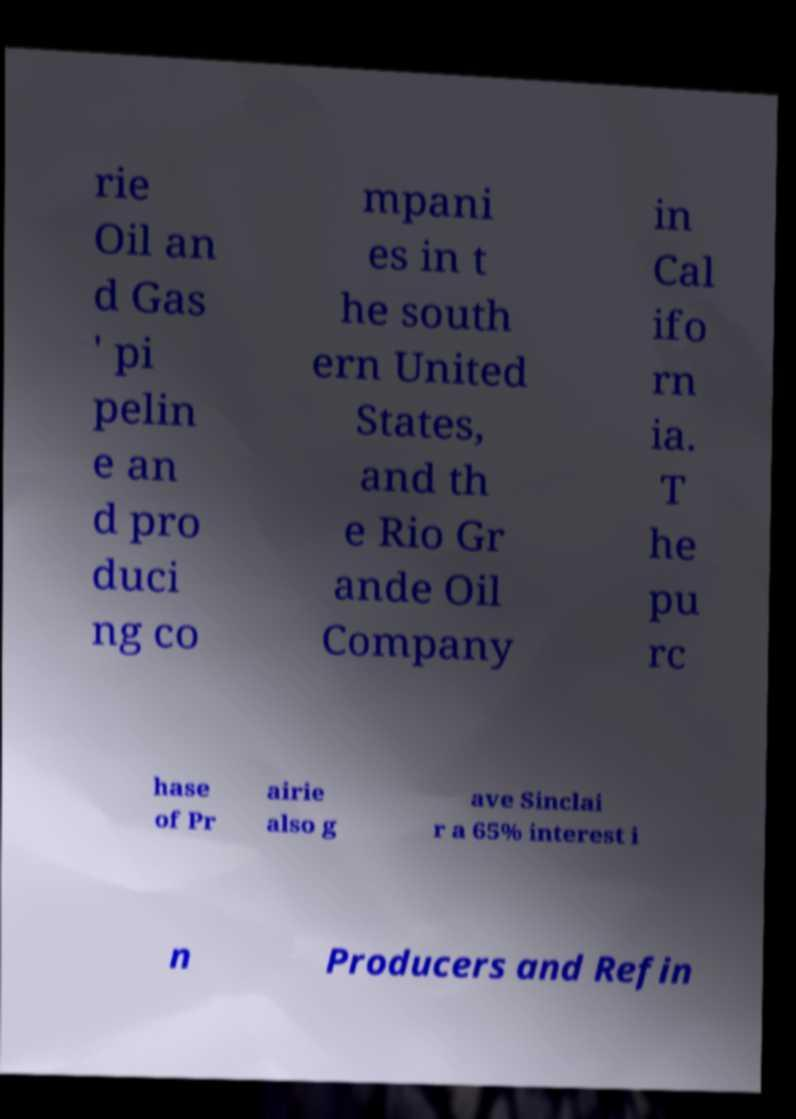There's text embedded in this image that I need extracted. Can you transcribe it verbatim? rie Oil an d Gas ' pi pelin e an d pro duci ng co mpani es in t he south ern United States, and th e Rio Gr ande Oil Company in Cal ifo rn ia. T he pu rc hase of Pr airie also g ave Sinclai r a 65% interest i n Producers and Refin 